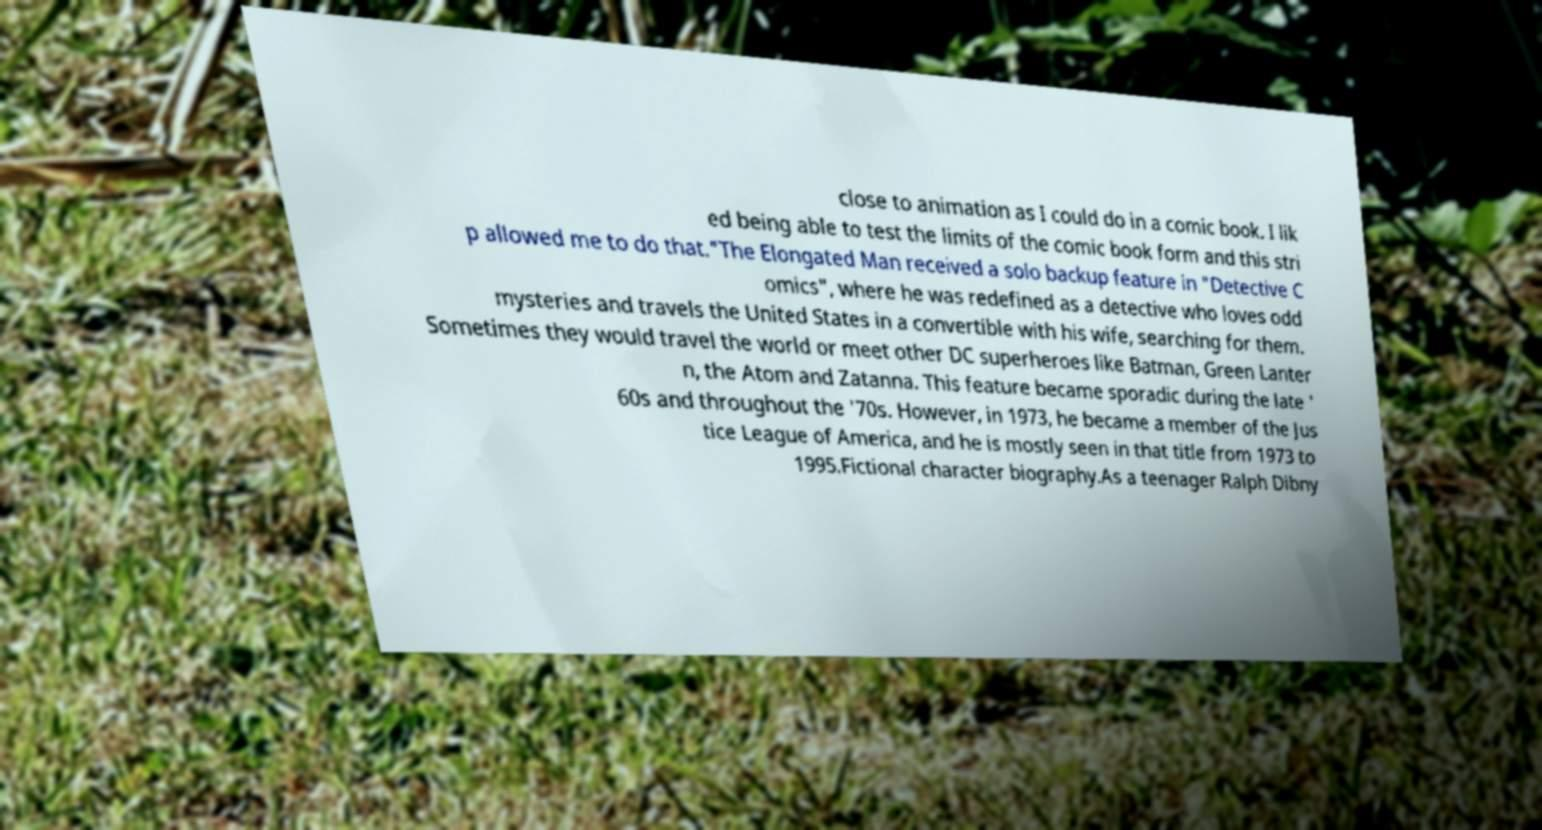Could you assist in decoding the text presented in this image and type it out clearly? close to animation as I could do in a comic book. I lik ed being able to test the limits of the comic book form and this stri p allowed me to do that."The Elongated Man received a solo backup feature in "Detective C omics", where he was redefined as a detective who loves odd mysteries and travels the United States in a convertible with his wife, searching for them. Sometimes they would travel the world or meet other DC superheroes like Batman, Green Lanter n, the Atom and Zatanna. This feature became sporadic during the late ' 60s and throughout the '70s. However, in 1973, he became a member of the Jus tice League of America, and he is mostly seen in that title from 1973 to 1995.Fictional character biography.As a teenager Ralph Dibny 